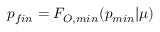Convert formula to latex. <formula><loc_0><loc_0><loc_500><loc_500>p _ { f i n } = F _ { O , \min } ( p _ { \min } | \mu )</formula> 